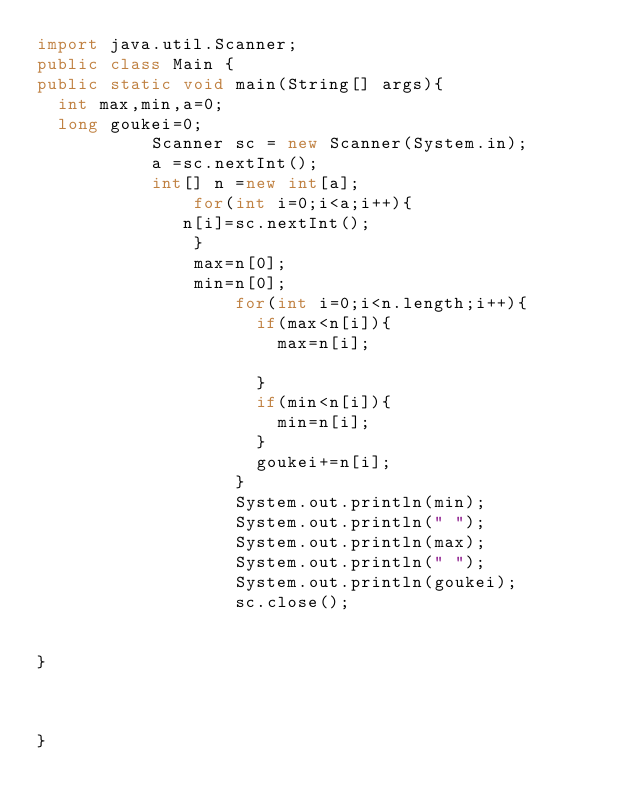Convert code to text. <code><loc_0><loc_0><loc_500><loc_500><_Java_>import java.util.Scanner;
public class Main {
public static void main(String[] args){
	int max,min,a=0;
	long goukei=0;
	         Scanner sc = new Scanner(System.in);
	         a =sc.nextInt();
	         int[] n =new int[a];
	        		 for(int i=0;i<a;i++){
	        		n[i]=sc.nextInt();	
	        		 }
	        		 max=n[0];
	        		 min=n[0];
	        				 for(int i=0;i<n.length;i++){ 
	        					 if(max<n[i]){
	        						 max=n[i];
	        						 
	        					 }
	        					 if(min<n[i]){
	        						 min=n[i];
	        					 }
	        					 goukei+=n[i];
	        				 }
	        				 System.out.println(min);
	        				 System.out.println(" ");
	        				 System.out.println(max);
	        				 System.out.println(" ");
	        				 System.out.println(goukei);
	        				 sc.close();
		    
	        	
}
	 		
	 		 
	   
}


</code> 